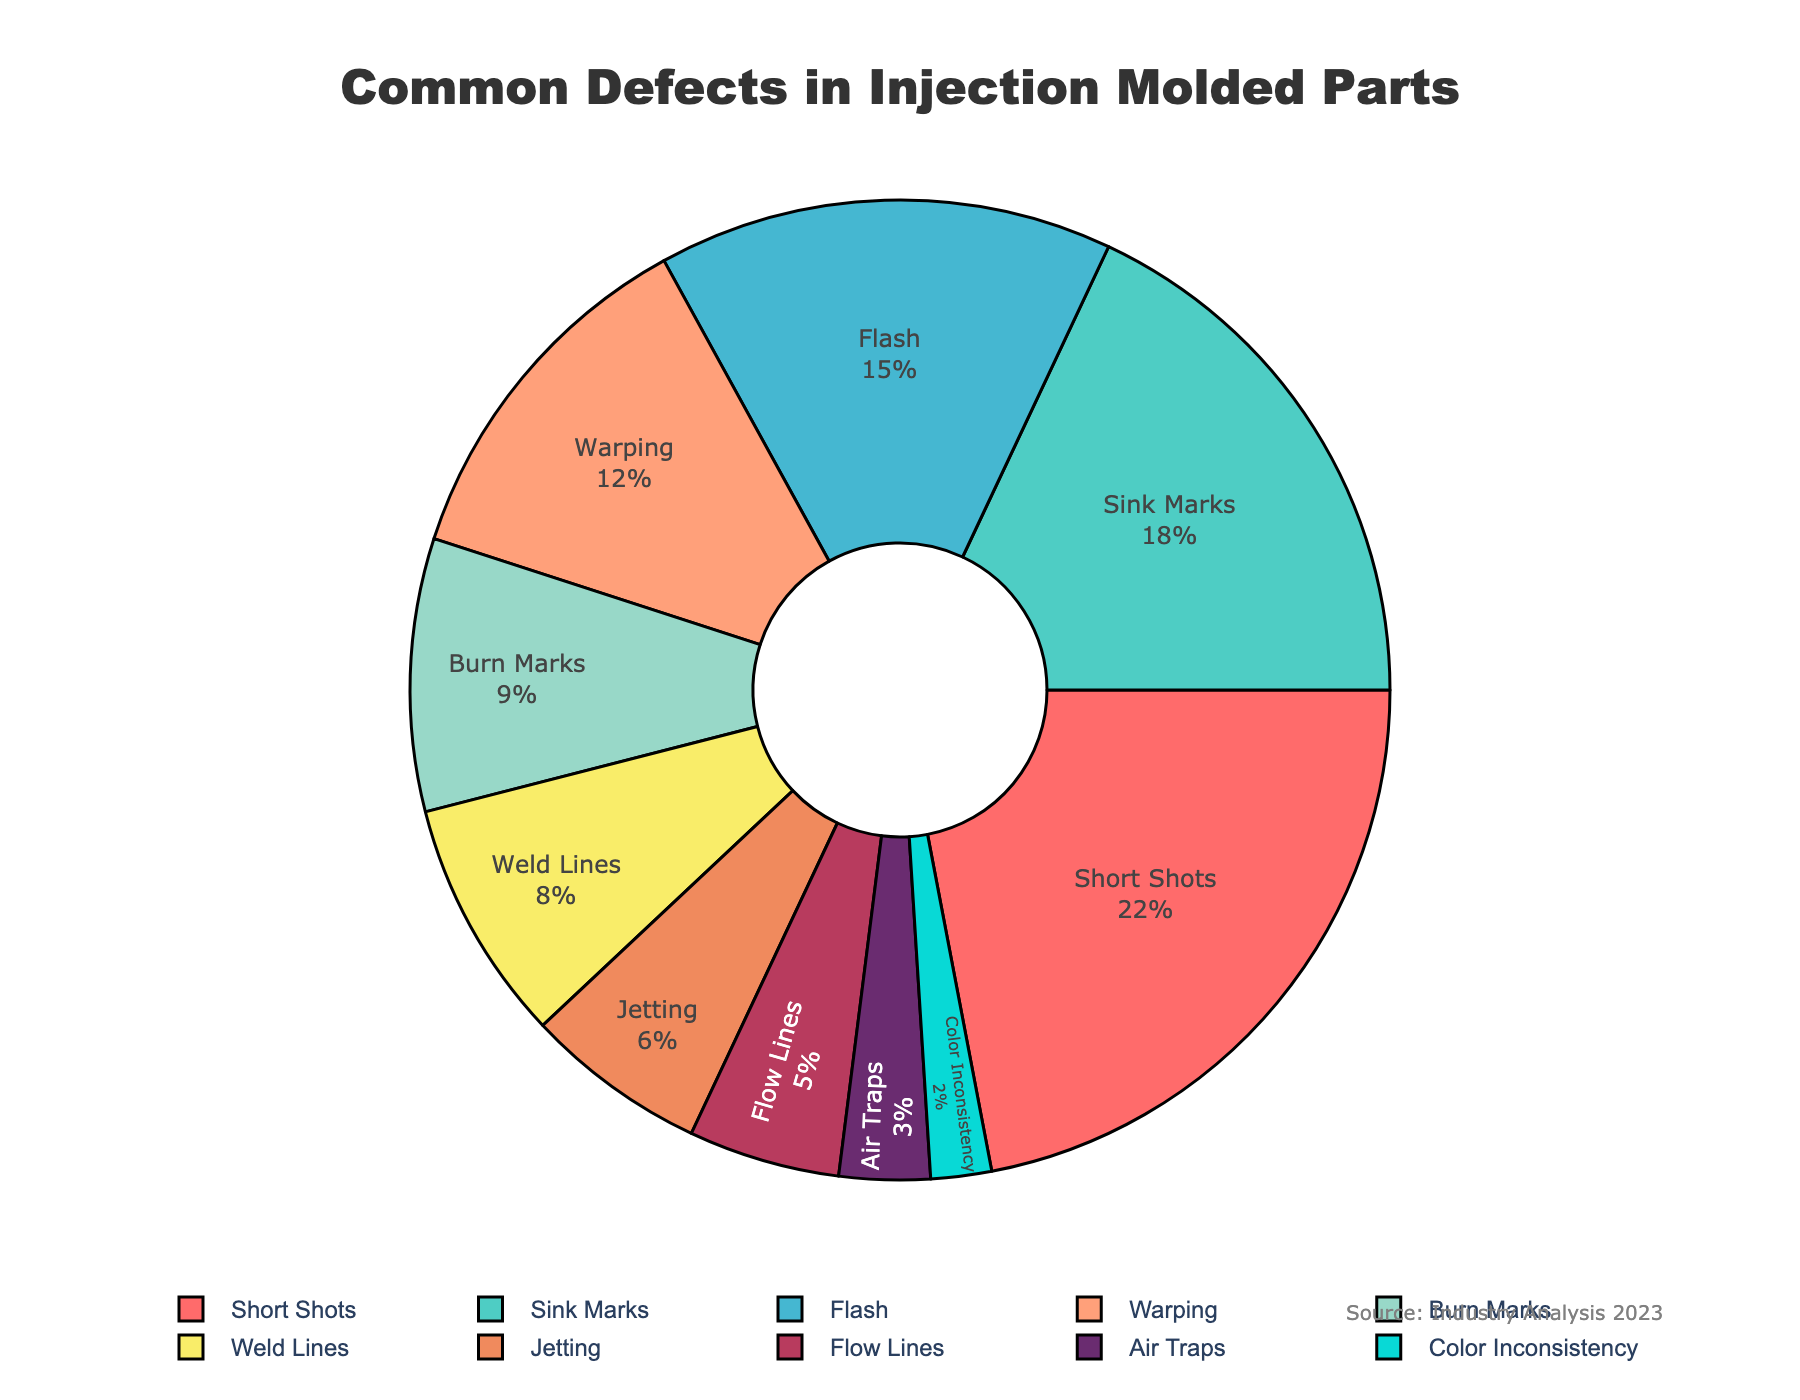Which defect type has the highest percentage? The highest percentage value in the pie chart is 22%, which corresponds to the defect type "Short Shots".
Answer: Short Shots How much larger is the percentage of Flash compared to Color Inconsistency? Flash has 15% whereas Color Inconsistency has 2%. The difference is calculated as 15% - 2% = 13%.
Answer: 13% Which defect types have a percentage of 9% or higher? By looking at the pie chart, the defect types with 9% or higher are Short Shots (22%), Sink Marks (18%), Flash (15%), and Warping (12%).
Answer: Short Shots, Sink Marks, Flash, and Warping What is the combined percentage of Jetting and Flow Lines? Jetting has 6% and Flow Lines have 5%. Combined, the total percentage is 6% + 5% = 11%.
Answer: 11% How does the percentage of Warp compared to Weld Lines? Warp has a percentage of 12%, while Weld Lines have 8%. Therefore, Warp has a higher percentage than Weld Lines.
Answer: Warp has a higher percentage Which three defect types have the smallest percentages? The defect types with the smallest percentages are Color Inconsistency (2%), Air Traps (3%), and Flow Lines (5%).
Answer: Color Inconsistency, Air Traps, Flow Lines If we group Short Shots, Sink Marks, and Flash together, what is their total percentage? Short Shots have 22%, Sink Marks have 18%, and Flash has 15%. The total percentage is 22% + 18% + 15% = 55%.
Answer: 55% Is the sum of the percentages of Sink Marks and Burn Marks greater than the percentage of Short Shots? Sink Marks are 18% and Burn Marks are 9%, which totals to 18% + 9% = 27%. This is not greater than 22% (the percentage of Short Shots).
Answer: No What proportion of the defects make up less than 10% each? The defects less than 10% are Burn Marks (9%), Weld Lines (8%), Jetting (6%), Flow Lines (5%), Air Traps (3%), and Color Inconsistency (2%). There are 6 such defects out of 10 total defects. The proportion is 6/10 = 60%.
Answer: 60% Which color is associated with the defect type having the highest percentage? The highest percentage (22%) corresponds to Short Shots. From the provided color palette, Short Shots is represented by the color red.
Answer: Red 